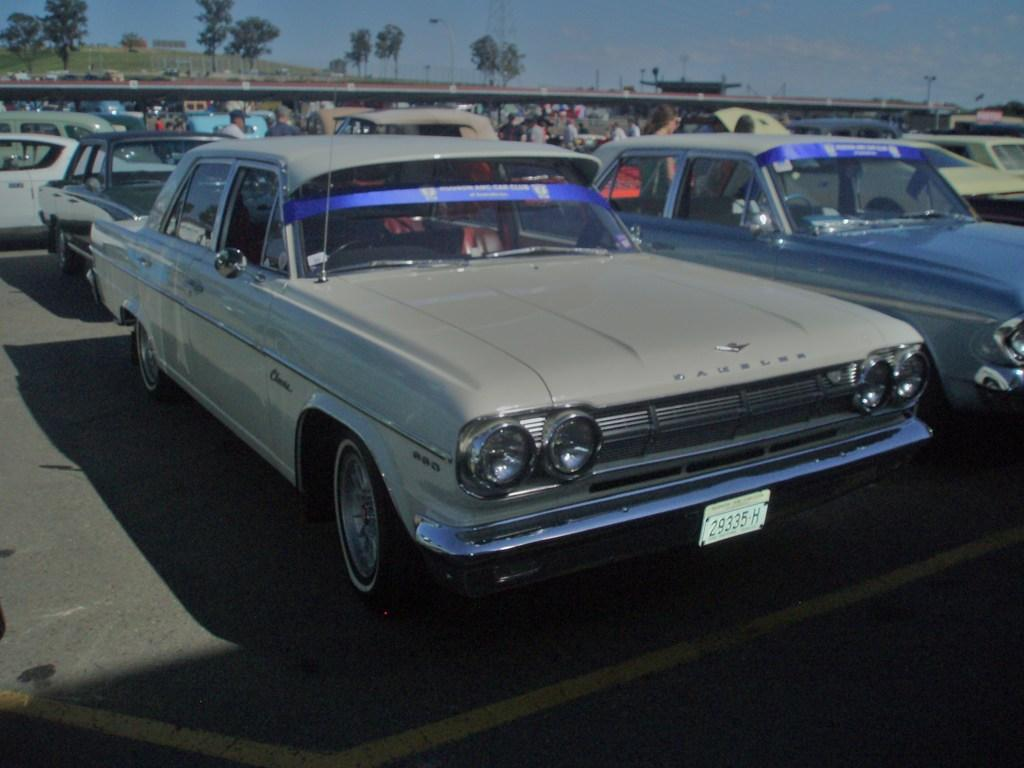<image>
Offer a succinct explanation of the picture presented. A silver car in a parking lot which has the letter H on the licence plate. 